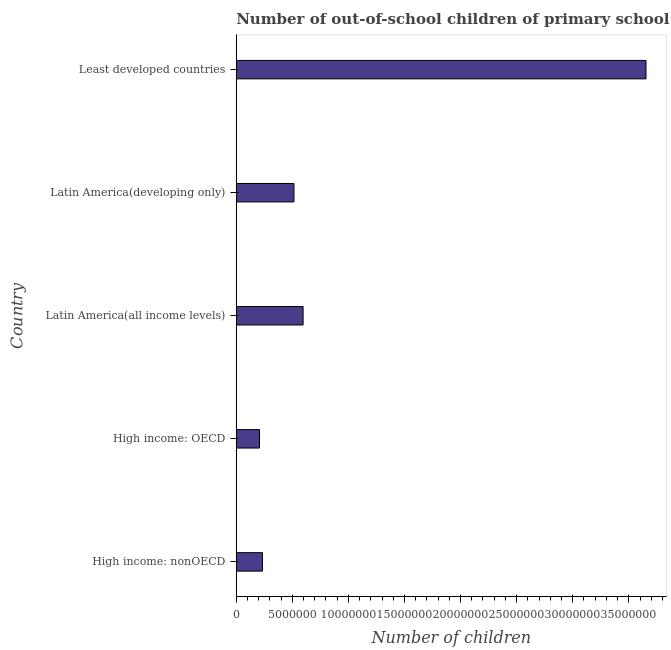What is the title of the graph?
Your response must be concise. Number of out-of-school children of primary school age in different countries. What is the label or title of the X-axis?
Give a very brief answer. Number of children. What is the label or title of the Y-axis?
Ensure brevity in your answer.  Country. What is the number of out-of-school children in Latin America(developing only)?
Provide a short and direct response. 5.14e+06. Across all countries, what is the maximum number of out-of-school children?
Give a very brief answer. 3.65e+07. Across all countries, what is the minimum number of out-of-school children?
Offer a very short reply. 2.07e+06. In which country was the number of out-of-school children maximum?
Make the answer very short. Least developed countries. In which country was the number of out-of-school children minimum?
Your response must be concise. High income: OECD. What is the sum of the number of out-of-school children?
Offer a terse response. 5.21e+07. What is the difference between the number of out-of-school children in High income: nonOECD and Latin America(all income levels)?
Offer a terse response. -3.62e+06. What is the average number of out-of-school children per country?
Ensure brevity in your answer.  1.04e+07. What is the median number of out-of-school children?
Your response must be concise. 5.14e+06. In how many countries, is the number of out-of-school children greater than 24000000 ?
Provide a short and direct response. 1. What is the ratio of the number of out-of-school children in High income: OECD to that in Latin America(developing only)?
Ensure brevity in your answer.  0.4. What is the difference between the highest and the second highest number of out-of-school children?
Your answer should be very brief. 3.06e+07. Is the sum of the number of out-of-school children in High income: OECD and High income: nonOECD greater than the maximum number of out-of-school children across all countries?
Give a very brief answer. No. What is the difference between the highest and the lowest number of out-of-school children?
Your answer should be compact. 3.45e+07. In how many countries, is the number of out-of-school children greater than the average number of out-of-school children taken over all countries?
Keep it short and to the point. 1. How many bars are there?
Offer a terse response. 5. How many countries are there in the graph?
Keep it short and to the point. 5. What is the Number of children in High income: nonOECD?
Offer a terse response. 2.34e+06. What is the Number of children of High income: OECD?
Offer a very short reply. 2.07e+06. What is the Number of children of Latin America(all income levels)?
Provide a short and direct response. 5.96e+06. What is the Number of children in Latin America(developing only)?
Offer a terse response. 5.14e+06. What is the Number of children in Least developed countries?
Ensure brevity in your answer.  3.65e+07. What is the difference between the Number of children in High income: nonOECD and High income: OECD?
Offer a terse response. 2.67e+05. What is the difference between the Number of children in High income: nonOECD and Latin America(all income levels)?
Your response must be concise. -3.62e+06. What is the difference between the Number of children in High income: nonOECD and Latin America(developing only)?
Make the answer very short. -2.80e+06. What is the difference between the Number of children in High income: nonOECD and Least developed countries?
Ensure brevity in your answer.  -3.42e+07. What is the difference between the Number of children in High income: OECD and Latin America(all income levels)?
Give a very brief answer. -3.89e+06. What is the difference between the Number of children in High income: OECD and Latin America(developing only)?
Provide a succinct answer. -3.07e+06. What is the difference between the Number of children in High income: OECD and Least developed countries?
Provide a short and direct response. -3.45e+07. What is the difference between the Number of children in Latin America(all income levels) and Latin America(developing only)?
Ensure brevity in your answer.  8.15e+05. What is the difference between the Number of children in Latin America(all income levels) and Least developed countries?
Provide a short and direct response. -3.06e+07. What is the difference between the Number of children in Latin America(developing only) and Least developed countries?
Your answer should be very brief. -3.14e+07. What is the ratio of the Number of children in High income: nonOECD to that in High income: OECD?
Provide a short and direct response. 1.13. What is the ratio of the Number of children in High income: nonOECD to that in Latin America(all income levels)?
Your response must be concise. 0.39. What is the ratio of the Number of children in High income: nonOECD to that in Latin America(developing only)?
Keep it short and to the point. 0.46. What is the ratio of the Number of children in High income: nonOECD to that in Least developed countries?
Your answer should be compact. 0.06. What is the ratio of the Number of children in High income: OECD to that in Latin America(all income levels)?
Give a very brief answer. 0.35. What is the ratio of the Number of children in High income: OECD to that in Latin America(developing only)?
Your answer should be very brief. 0.4. What is the ratio of the Number of children in High income: OECD to that in Least developed countries?
Keep it short and to the point. 0.06. What is the ratio of the Number of children in Latin America(all income levels) to that in Latin America(developing only)?
Your response must be concise. 1.16. What is the ratio of the Number of children in Latin America(all income levels) to that in Least developed countries?
Provide a short and direct response. 0.16. What is the ratio of the Number of children in Latin America(developing only) to that in Least developed countries?
Your answer should be very brief. 0.14. 